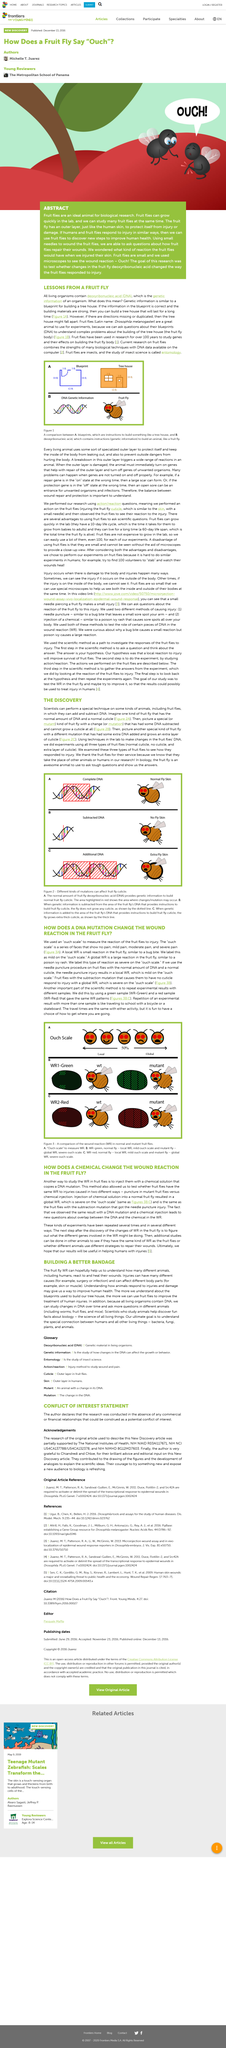Indicate a few pertinent items in this graphic. The purpose of this research was to investigate the effects of alterations in fruit fly deoxyribonucleic acid (DNA) on the manner in which the fruit flies responded to injury. The study aimed to investigate the reaction of fruitflies upon exposure to a chemical solution that simulates a DNA mutation, in order to identify any potential effects on the insect's behavior. I declare that small needles are used to wound fruit flies. The insect in the image is a fruit fly, a type of insect commonly found in fruit and vegetable products. A chemical change in a fruit fly's wound reaction has been observed to result in a global writhing response. 